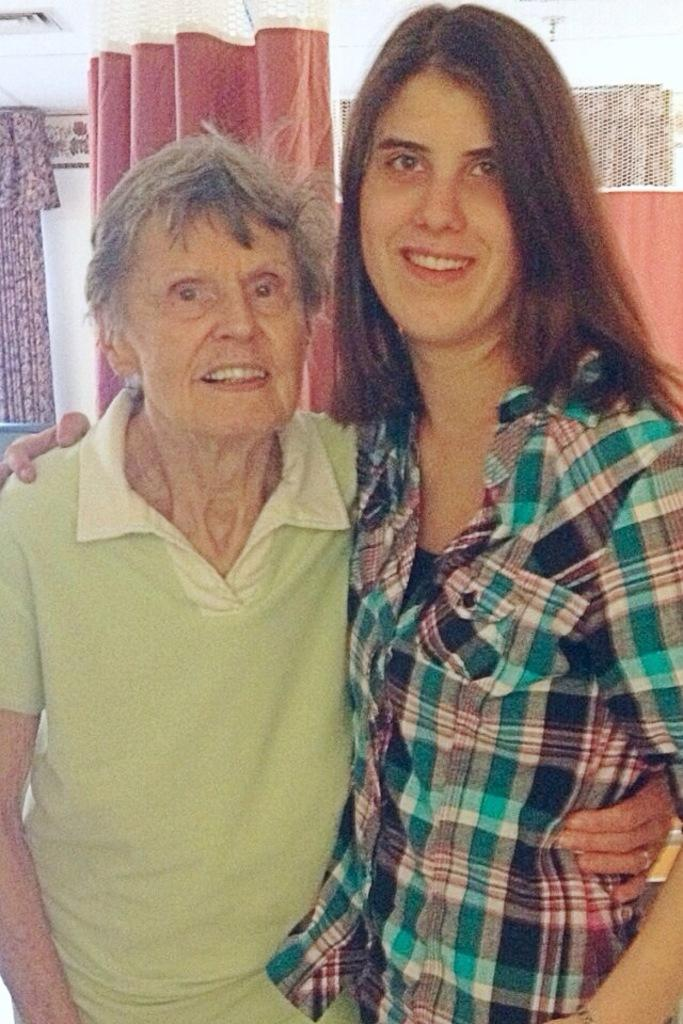Who is the main subject in the image? There is an old man in the image. What is the old man wearing? The old man is wearing a green t-shirt. What is the old man doing in the image? The old man is holding a woman. What type of window treatment is present in the image? There are curtains in the image. Where are the curtains located in relation to the wall? The curtains are in front of a wall. What type of comb is the old man using in the image? There is no comb present in the image. 